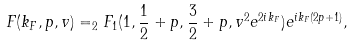Convert formula to latex. <formula><loc_0><loc_0><loc_500><loc_500>F ( k _ { F } , p , v ) = _ { 2 } F _ { 1 } ( 1 , \frac { 1 } { 2 } + p , \frac { 3 } { 2 } + p , v ^ { 2 } e ^ { 2 i k _ { F } } ) e ^ { i k _ { F } ( 2 p + 1 ) } ,</formula> 